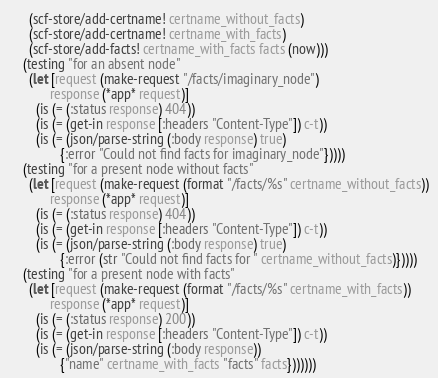<code> <loc_0><loc_0><loc_500><loc_500><_Clojure_>      (scf-store/add-certname! certname_without_facts)
      (scf-store/add-certname! certname_with_facts)
      (scf-store/add-facts! certname_with_facts facts (now)))
    (testing "for an absent node"
      (let [request (make-request "/facts/imaginary_node")
            response (*app* request)]
        (is (= (:status response) 404))
        (is (= (get-in response [:headers "Content-Type"]) c-t))
        (is (= (json/parse-string (:body response) true)
               {:error "Could not find facts for imaginary_node"}))))
    (testing "for a present node without facts"
      (let [request (make-request (format "/facts/%s" certname_without_facts))
            response (*app* request)]
        (is (= (:status response) 404))
        (is (= (get-in response [:headers "Content-Type"]) c-t))
        (is (= (json/parse-string (:body response) true)
               {:error (str "Could not find facts for " certname_without_facts)}))))
    (testing "for a present node with facts"
      (let [request (make-request (format "/facts/%s" certname_with_facts))
            response (*app* request)]
        (is (= (:status response) 200))
        (is (= (get-in response [:headers "Content-Type"]) c-t))
        (is (= (json/parse-string (:body response))
               {"name" certname_with_facts "facts" facts}))))))
</code> 